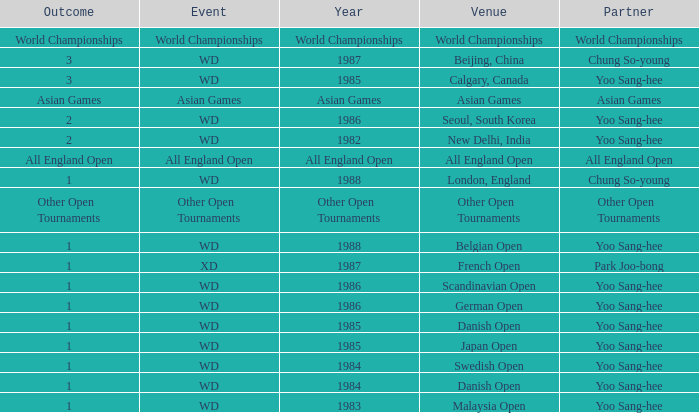What was the upshot in 1983 of the wd happening? 1.0. 